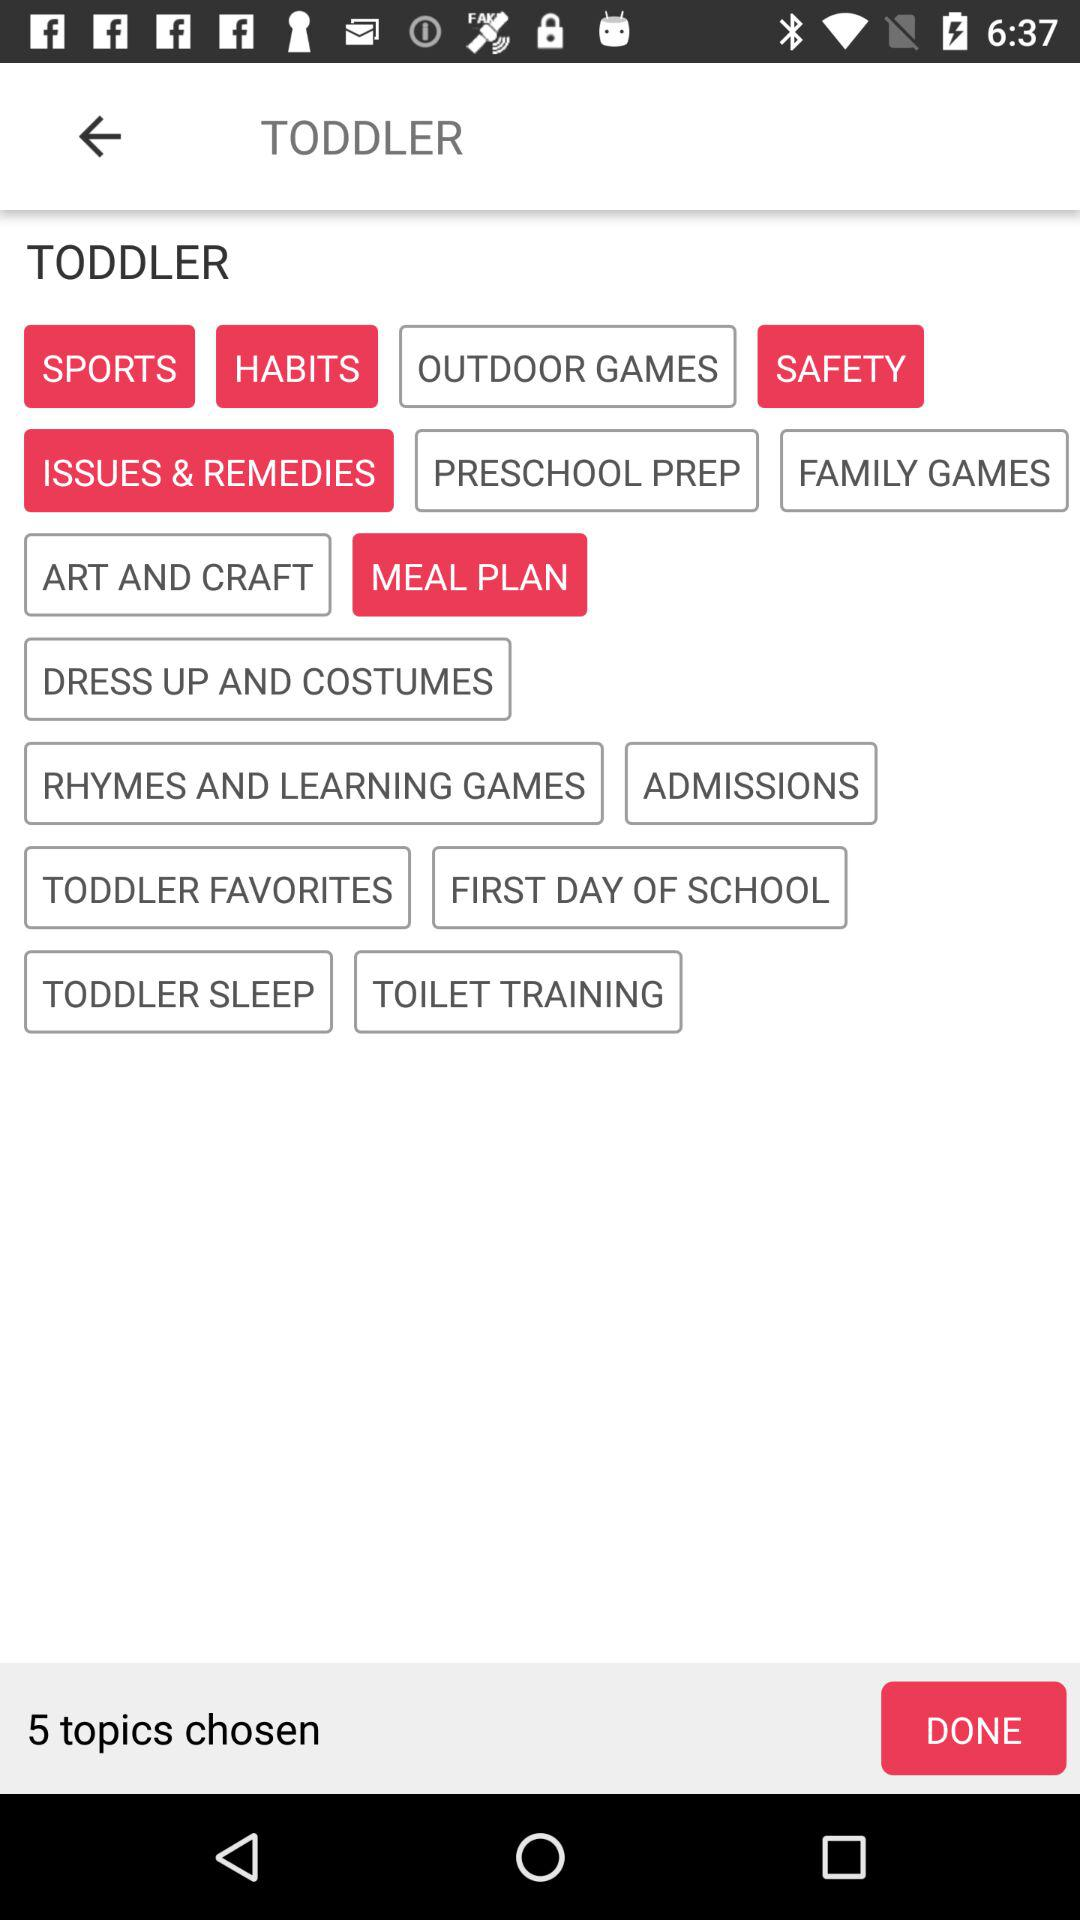What are the selected topics? The selected topics are "SPORTS", "HABITS", "SAFETY", "ISSUES & REMEDIES" and "MEAL PLAN". 